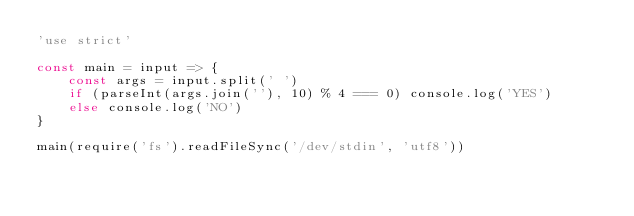Convert code to text. <code><loc_0><loc_0><loc_500><loc_500><_JavaScript_>'use strict'

const main = input => {
	const args = input.split(' ')
	if (parseInt(args.join(''), 10) % 4 === 0) console.log('YES')
	else console.log('NO')
}

main(require('fs').readFileSync('/dev/stdin', 'utf8'))
</code> 